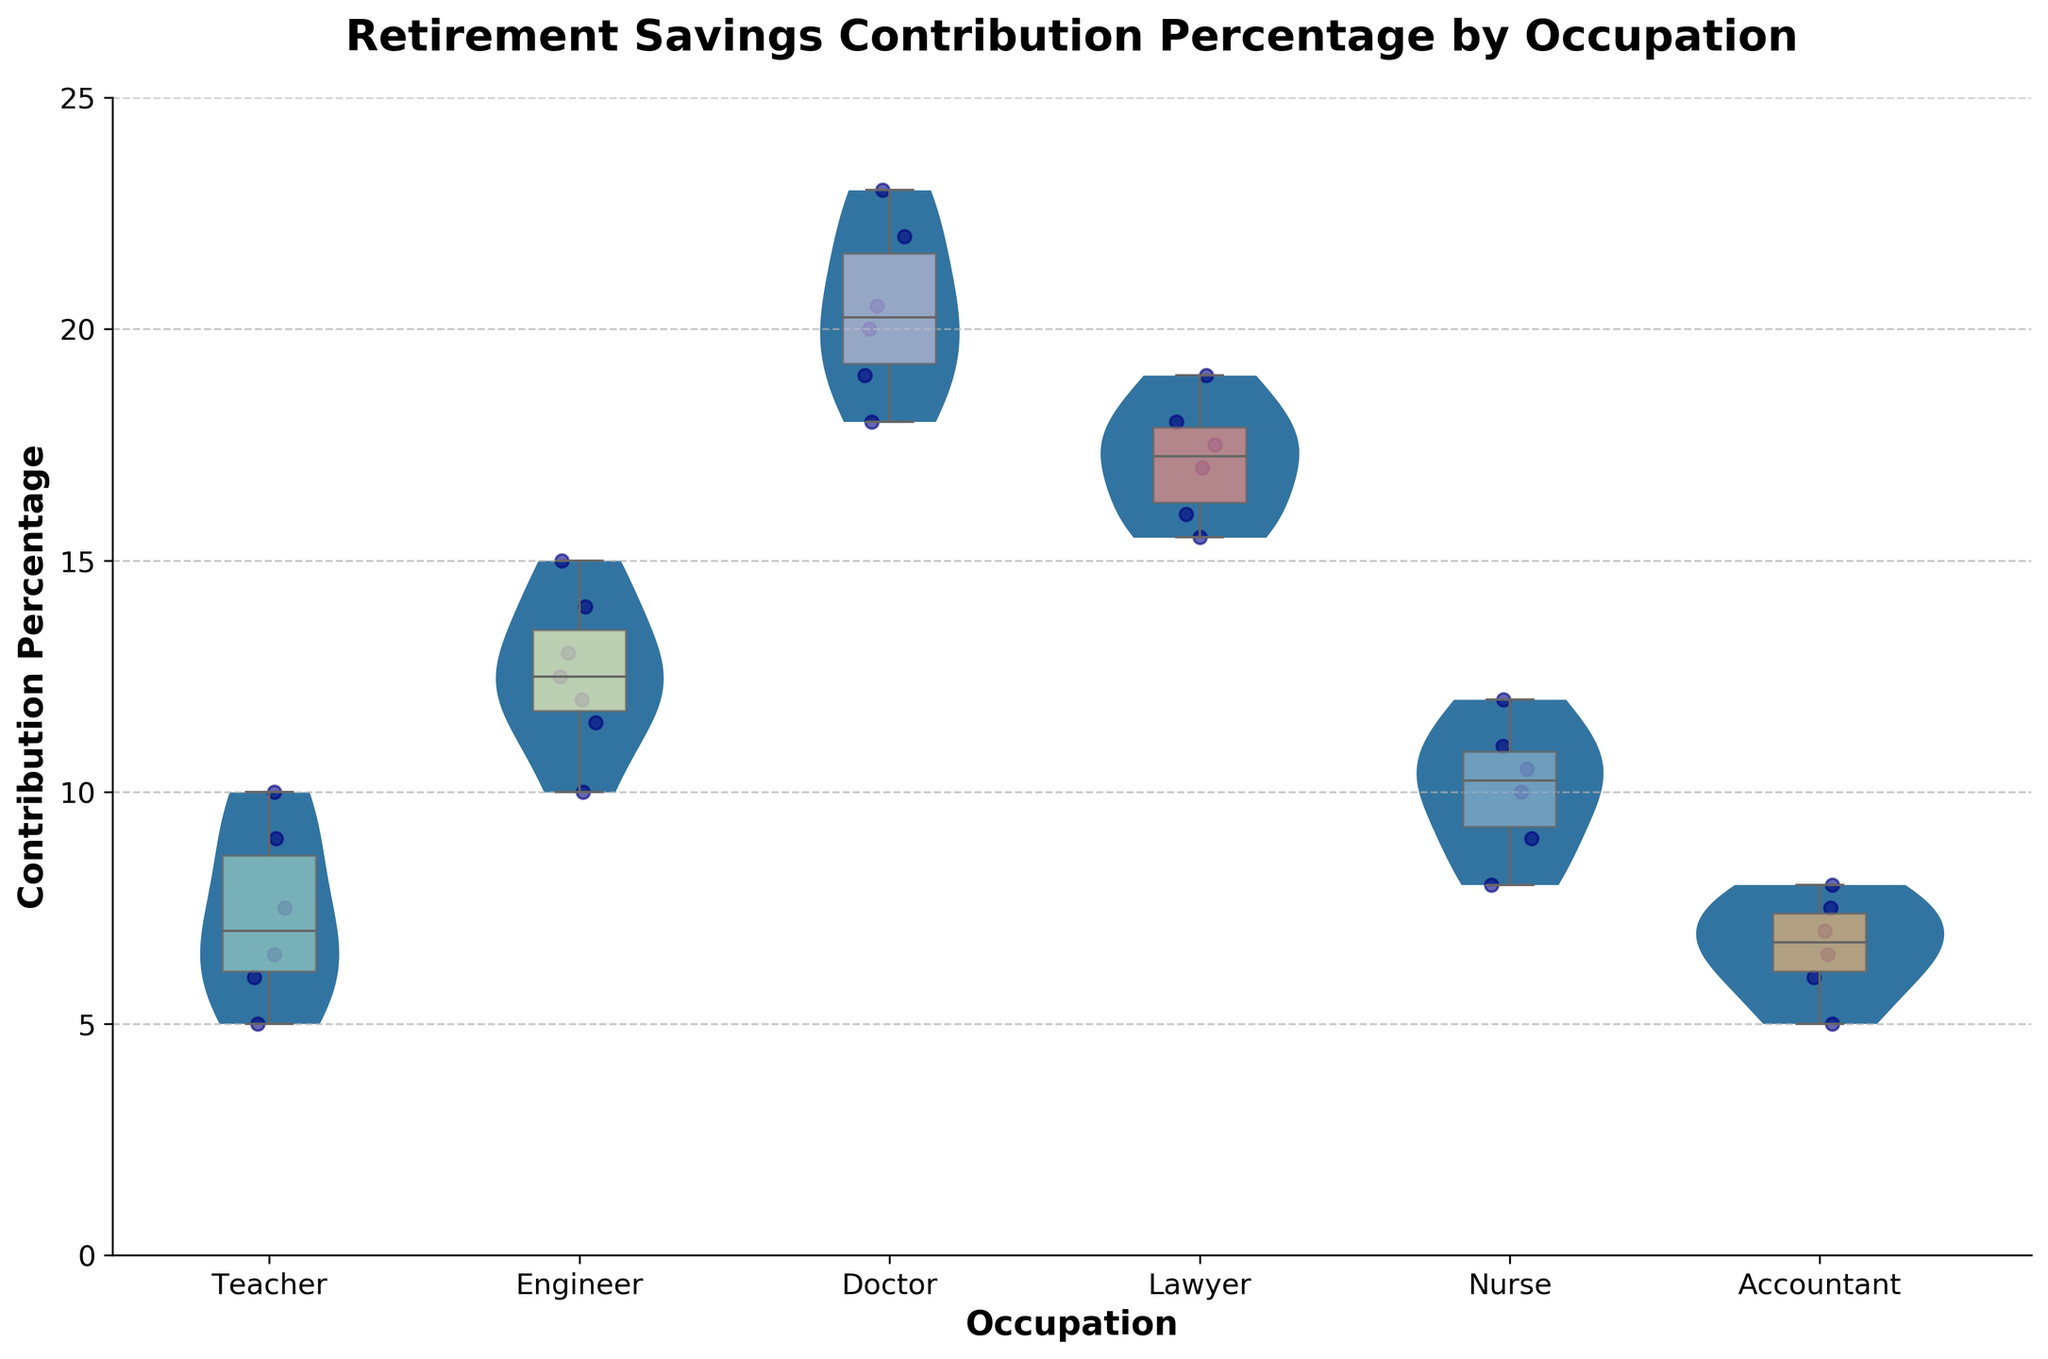What is the title of the plot? The title is usually found at the top of the plot and is clearly labeled.
Answer: Retirement Savings Contribution Percentage by Occupation What does the y-axis represent? The y-axis label provides details about the data being measured. Here, it represents the percentage of retirement savings contributions.
Answer: Contribution Percentage Which occupation shows the highest median contribution percentage? The median is indicated by the line inside the box in the box plot within each violin. For Doctors, this line is at the highest position.
Answer: Doctor How many distinct occupational categories are shown in this plot? By counting the number of violins or box plots along the x-axis, we can determine the number of categories.
Answer: 6 What is the approximate median contribution percentage for Engineers? Looking at the line inside the box for Engineers, the median falls around 12%.
Answer: 12% Which occupation has the widest range of contribution percentages? The range in contribution percentages can be determined by observing the height of the violin plot. The Doctors have the widest range.
Answer: Doctor Compare the median contribution percentages between Nurses and Lawyers. Which is higher? The line inside the box for each occupation shows the median. Nurses have a median around 10.5%, while Lawyers have a median around 17.5%.
Answer: Lawyer What is the approximate interquartile range (IQR) for Teachers? The IQR is the range between the top and bottom of the box. For Teachers, it looks roughly between 6 and 8.5, making the IQR about 2.5.
Answer: 2.5 Which occupation has the most concentrated contribution percentages? The concentration of data points is revealed by the narrowest part of the violin plot. Accountants show the most concentrated contributions.
Answer: Accountant How does the spread of contribution percentages for Nurses compare to that for Engineers? Nurses have a more varied spread, with a wider and more skewed violin, whereas Engineers have a more evenly distributed and slightly narrower violin.
Answer: Nurses have a wider spread than Engineers 